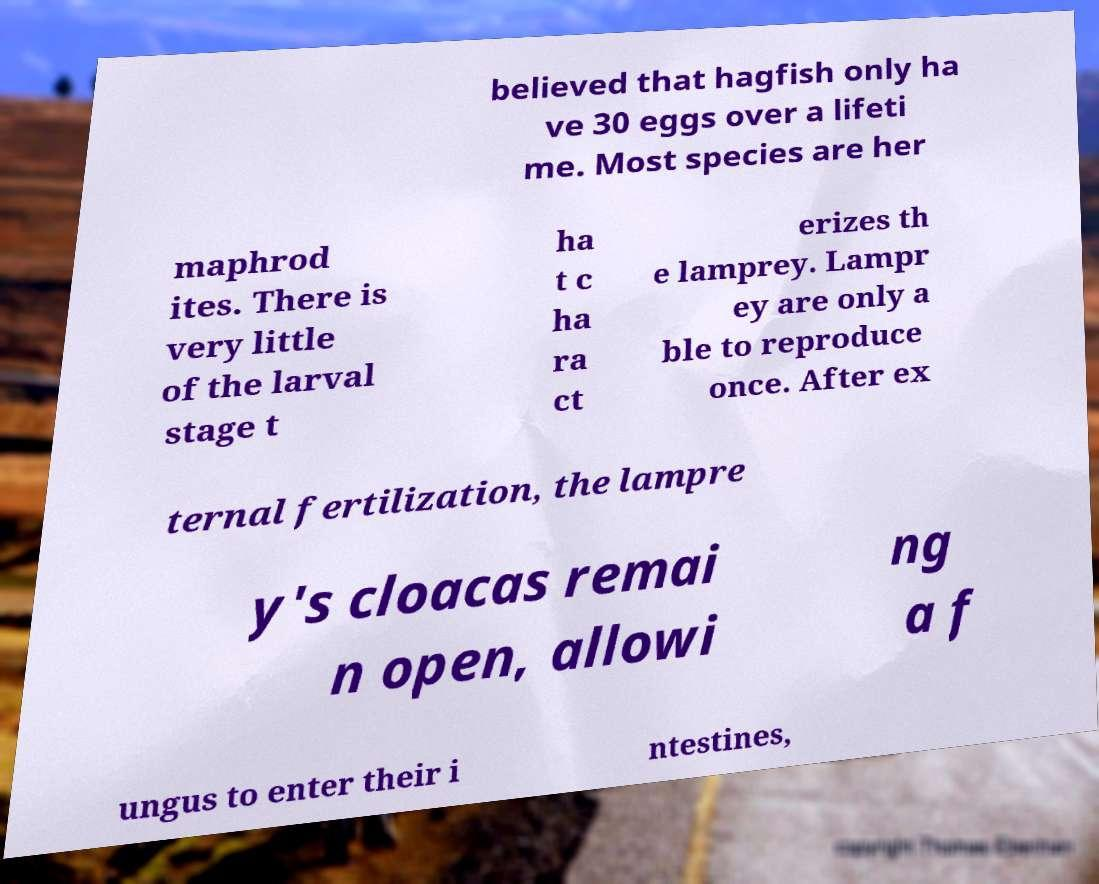Please read and relay the text visible in this image. What does it say? believed that hagfish only ha ve 30 eggs over a lifeti me. Most species are her maphrod ites. There is very little of the larval stage t ha t c ha ra ct erizes th e lamprey. Lampr ey are only a ble to reproduce once. After ex ternal fertilization, the lampre y's cloacas remai n open, allowi ng a f ungus to enter their i ntestines, 